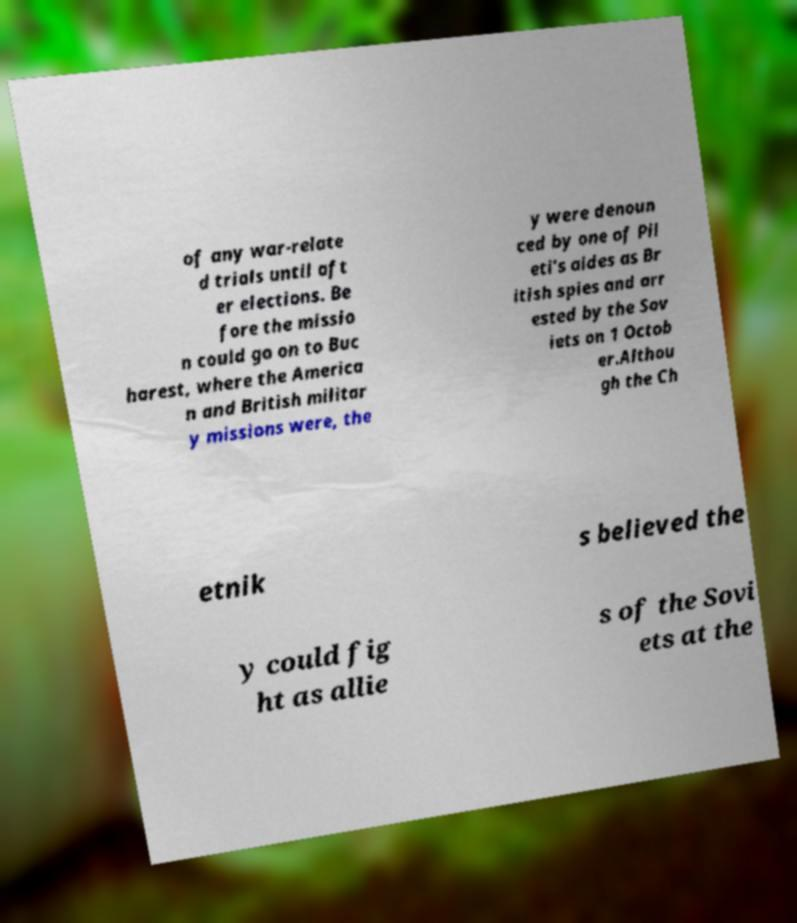Can you read and provide the text displayed in the image?This photo seems to have some interesting text. Can you extract and type it out for me? of any war-relate d trials until aft er elections. Be fore the missio n could go on to Buc harest, where the America n and British militar y missions were, the y were denoun ced by one of Pil eti's aides as Br itish spies and arr ested by the Sov iets on 1 Octob er.Althou gh the Ch etnik s believed the y could fig ht as allie s of the Sovi ets at the 